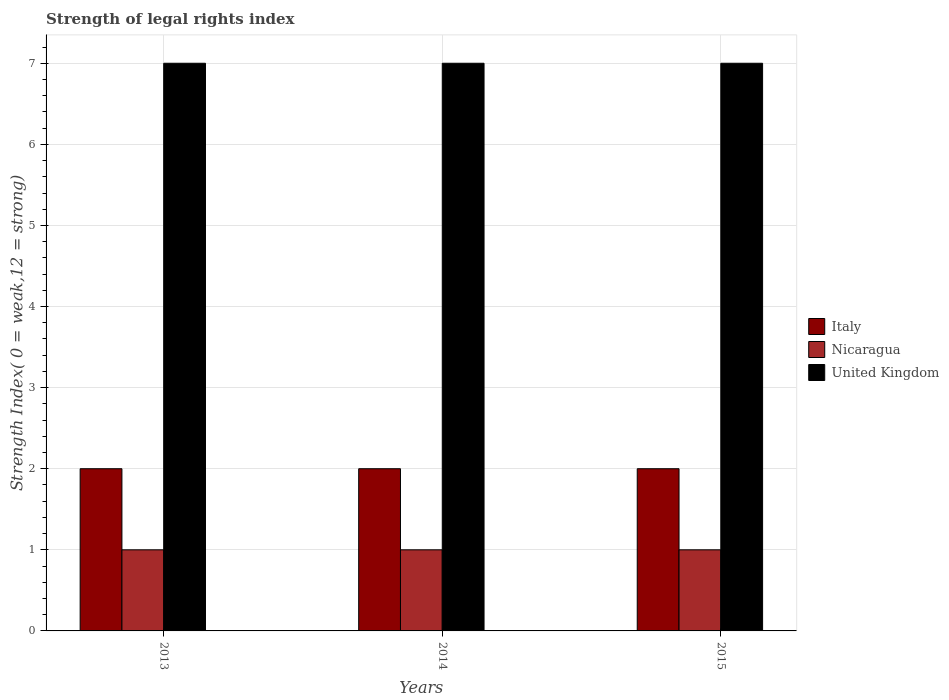How many different coloured bars are there?
Your response must be concise. 3. How many groups of bars are there?
Give a very brief answer. 3. Are the number of bars per tick equal to the number of legend labels?
Your answer should be compact. Yes. Are the number of bars on each tick of the X-axis equal?
Provide a short and direct response. Yes. How many bars are there on the 2nd tick from the left?
Your answer should be compact. 3. How many bars are there on the 1st tick from the right?
Provide a succinct answer. 3. What is the label of the 2nd group of bars from the left?
Offer a very short reply. 2014. In how many cases, is the number of bars for a given year not equal to the number of legend labels?
Offer a terse response. 0. What is the strength index in United Kingdom in 2014?
Provide a short and direct response. 7. Across all years, what is the maximum strength index in United Kingdom?
Provide a succinct answer. 7. Across all years, what is the minimum strength index in Nicaragua?
Your response must be concise. 1. What is the total strength index in Nicaragua in the graph?
Keep it short and to the point. 3. What is the difference between the strength index in Italy in 2013 and that in 2015?
Provide a succinct answer. 0. What is the difference between the strength index in Italy in 2014 and the strength index in Nicaragua in 2013?
Give a very brief answer. 1. What is the average strength index in Italy per year?
Ensure brevity in your answer.  2. In the year 2014, what is the difference between the strength index in Nicaragua and strength index in Italy?
Offer a terse response. -1. In how many years, is the strength index in United Kingdom greater than 4.2?
Provide a succinct answer. 3. How many bars are there?
Provide a succinct answer. 9. How many years are there in the graph?
Provide a succinct answer. 3. What is the difference between two consecutive major ticks on the Y-axis?
Provide a succinct answer. 1. Are the values on the major ticks of Y-axis written in scientific E-notation?
Keep it short and to the point. No. Does the graph contain any zero values?
Your answer should be very brief. No. Does the graph contain grids?
Provide a short and direct response. Yes. How many legend labels are there?
Give a very brief answer. 3. How are the legend labels stacked?
Offer a very short reply. Vertical. What is the title of the graph?
Your response must be concise. Strength of legal rights index. What is the label or title of the Y-axis?
Your answer should be very brief. Strength Index( 0 = weak,12 = strong). What is the Strength Index( 0 = weak,12 = strong) of Italy in 2013?
Give a very brief answer. 2. What is the Strength Index( 0 = weak,12 = strong) in Italy in 2014?
Provide a short and direct response. 2. What is the Strength Index( 0 = weak,12 = strong) in Nicaragua in 2014?
Make the answer very short. 1. What is the Strength Index( 0 = weak,12 = strong) in Nicaragua in 2015?
Give a very brief answer. 1. What is the Strength Index( 0 = weak,12 = strong) of United Kingdom in 2015?
Provide a succinct answer. 7. Across all years, what is the maximum Strength Index( 0 = weak,12 = strong) of Italy?
Give a very brief answer. 2. Across all years, what is the maximum Strength Index( 0 = weak,12 = strong) in Nicaragua?
Offer a very short reply. 1. Across all years, what is the minimum Strength Index( 0 = weak,12 = strong) in United Kingdom?
Your response must be concise. 7. What is the total Strength Index( 0 = weak,12 = strong) in Italy in the graph?
Offer a very short reply. 6. What is the total Strength Index( 0 = weak,12 = strong) of Nicaragua in the graph?
Offer a very short reply. 3. What is the difference between the Strength Index( 0 = weak,12 = strong) in Italy in 2013 and that in 2014?
Your response must be concise. 0. What is the difference between the Strength Index( 0 = weak,12 = strong) in Nicaragua in 2013 and that in 2015?
Give a very brief answer. 0. What is the difference between the Strength Index( 0 = weak,12 = strong) of United Kingdom in 2013 and that in 2015?
Your response must be concise. 0. What is the difference between the Strength Index( 0 = weak,12 = strong) of Italy in 2014 and that in 2015?
Your answer should be compact. 0. What is the difference between the Strength Index( 0 = weak,12 = strong) of United Kingdom in 2014 and that in 2015?
Provide a short and direct response. 0. What is the difference between the Strength Index( 0 = weak,12 = strong) of Nicaragua in 2013 and the Strength Index( 0 = weak,12 = strong) of United Kingdom in 2014?
Your answer should be very brief. -6. What is the difference between the Strength Index( 0 = weak,12 = strong) of Italy in 2013 and the Strength Index( 0 = weak,12 = strong) of Nicaragua in 2015?
Your response must be concise. 1. What is the difference between the Strength Index( 0 = weak,12 = strong) of Italy in 2013 and the Strength Index( 0 = weak,12 = strong) of United Kingdom in 2015?
Provide a succinct answer. -5. What is the average Strength Index( 0 = weak,12 = strong) in Italy per year?
Provide a short and direct response. 2. What is the average Strength Index( 0 = weak,12 = strong) in Nicaragua per year?
Your response must be concise. 1. In the year 2013, what is the difference between the Strength Index( 0 = weak,12 = strong) of Italy and Strength Index( 0 = weak,12 = strong) of Nicaragua?
Your answer should be compact. 1. In the year 2013, what is the difference between the Strength Index( 0 = weak,12 = strong) in Italy and Strength Index( 0 = weak,12 = strong) in United Kingdom?
Your answer should be very brief. -5. In the year 2013, what is the difference between the Strength Index( 0 = weak,12 = strong) in Nicaragua and Strength Index( 0 = weak,12 = strong) in United Kingdom?
Keep it short and to the point. -6. What is the ratio of the Strength Index( 0 = weak,12 = strong) of United Kingdom in 2013 to that in 2014?
Provide a succinct answer. 1. What is the ratio of the Strength Index( 0 = weak,12 = strong) of Italy in 2013 to that in 2015?
Your answer should be very brief. 1. What is the ratio of the Strength Index( 0 = weak,12 = strong) of Nicaragua in 2013 to that in 2015?
Ensure brevity in your answer.  1. What is the ratio of the Strength Index( 0 = weak,12 = strong) in Italy in 2014 to that in 2015?
Offer a very short reply. 1. What is the ratio of the Strength Index( 0 = weak,12 = strong) of Nicaragua in 2014 to that in 2015?
Offer a very short reply. 1. What is the difference between the highest and the second highest Strength Index( 0 = weak,12 = strong) of United Kingdom?
Offer a very short reply. 0. 